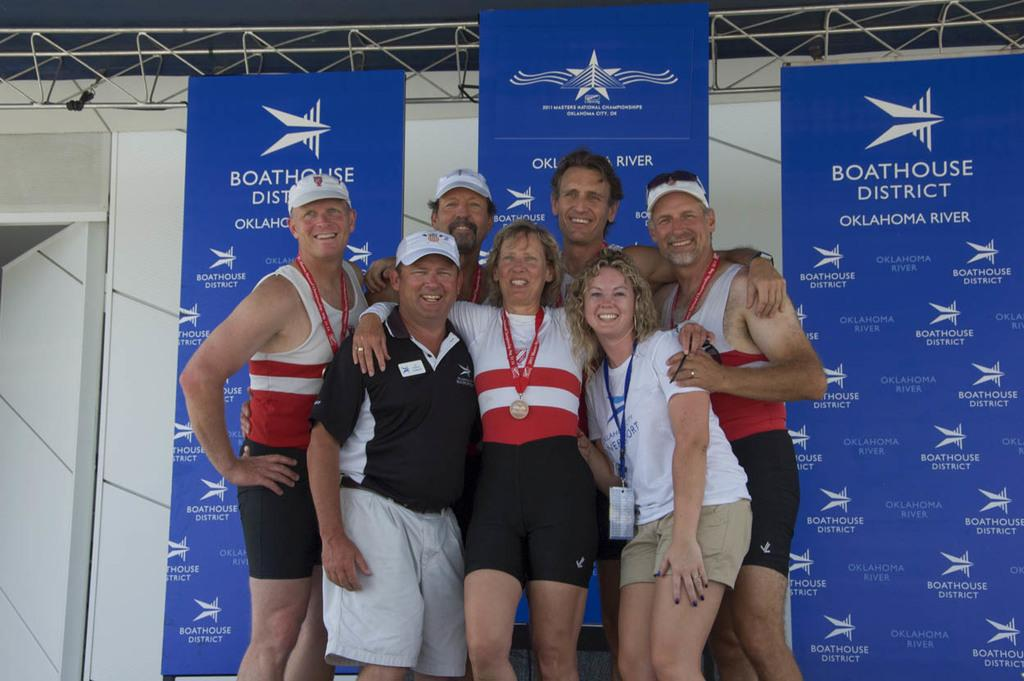<image>
Give a short and clear explanation of the subsequent image. A group of people posing for a photo in front of a poster for Boathouse District Oklahoma River. 